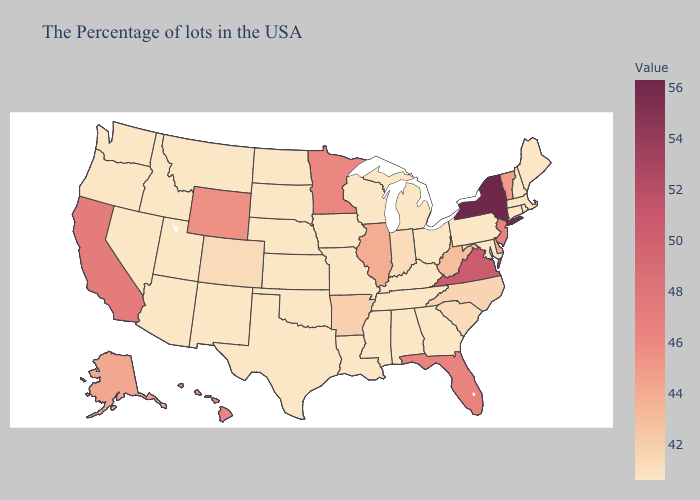Does the map have missing data?
Give a very brief answer. No. Does Texas have the lowest value in the USA?
Be succinct. Yes. Among the states that border New Hampshire , which have the highest value?
Short answer required. Vermont. Which states have the lowest value in the South?
Answer briefly. Maryland, Georgia, Kentucky, Alabama, Tennessee, Mississippi, Louisiana, Oklahoma, Texas. Does Oklahoma have the lowest value in the South?
Short answer required. Yes. Does California have a higher value than New York?
Answer briefly. No. Is the legend a continuous bar?
Be succinct. Yes. 